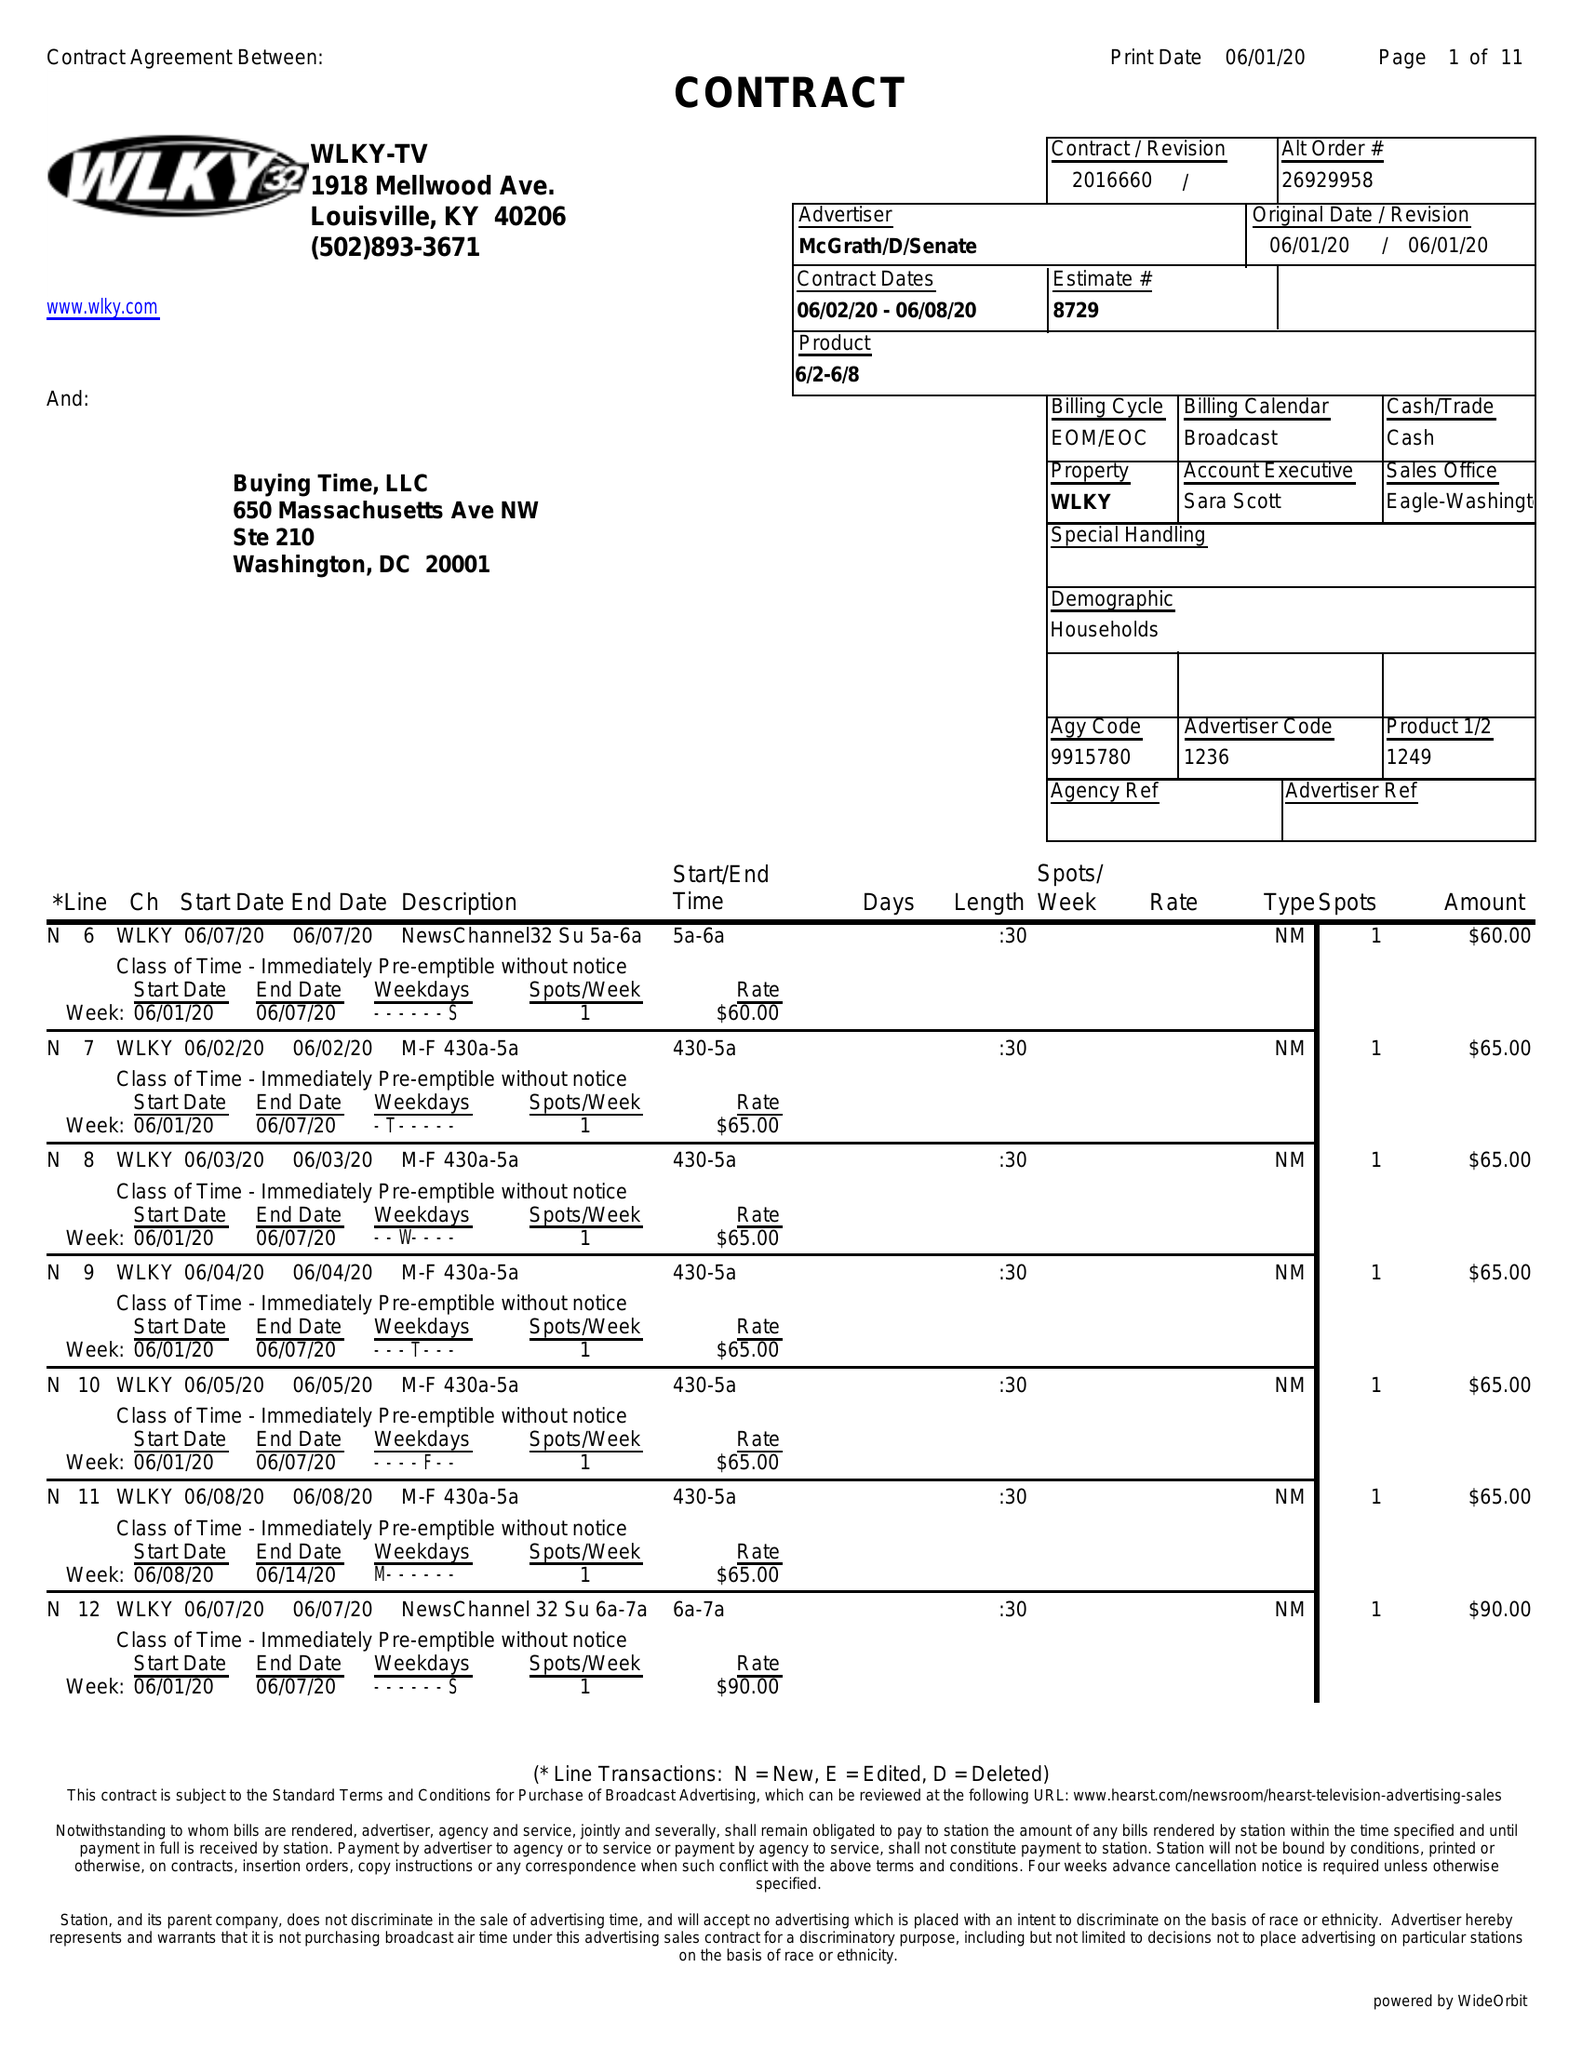What is the value for the gross_amount?
Answer the question using a single word or phrase. 17545.00 